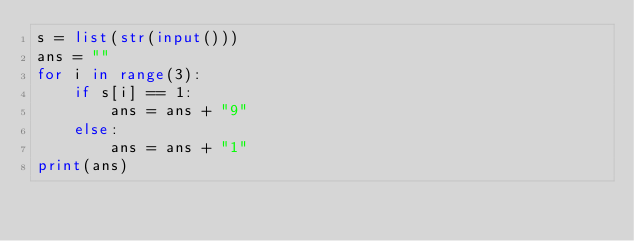<code> <loc_0><loc_0><loc_500><loc_500><_Python_>s = list(str(input()))
ans = ""
for i in range(3):
    if s[i] == 1:
        ans = ans + "9"
    else:
        ans = ans + "1"
print(ans)
</code> 